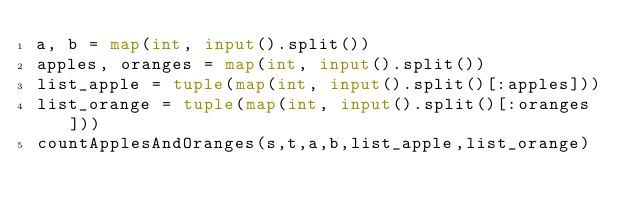<code> <loc_0><loc_0><loc_500><loc_500><_Python_>a, b = map(int, input().split())
apples, oranges = map(int, input().split())
list_apple = tuple(map(int, input().split()[:apples]))
list_orange = tuple(map(int, input().split()[:oranges]))
countApplesAndOranges(s,t,a,b,list_apple,list_orange)</code> 